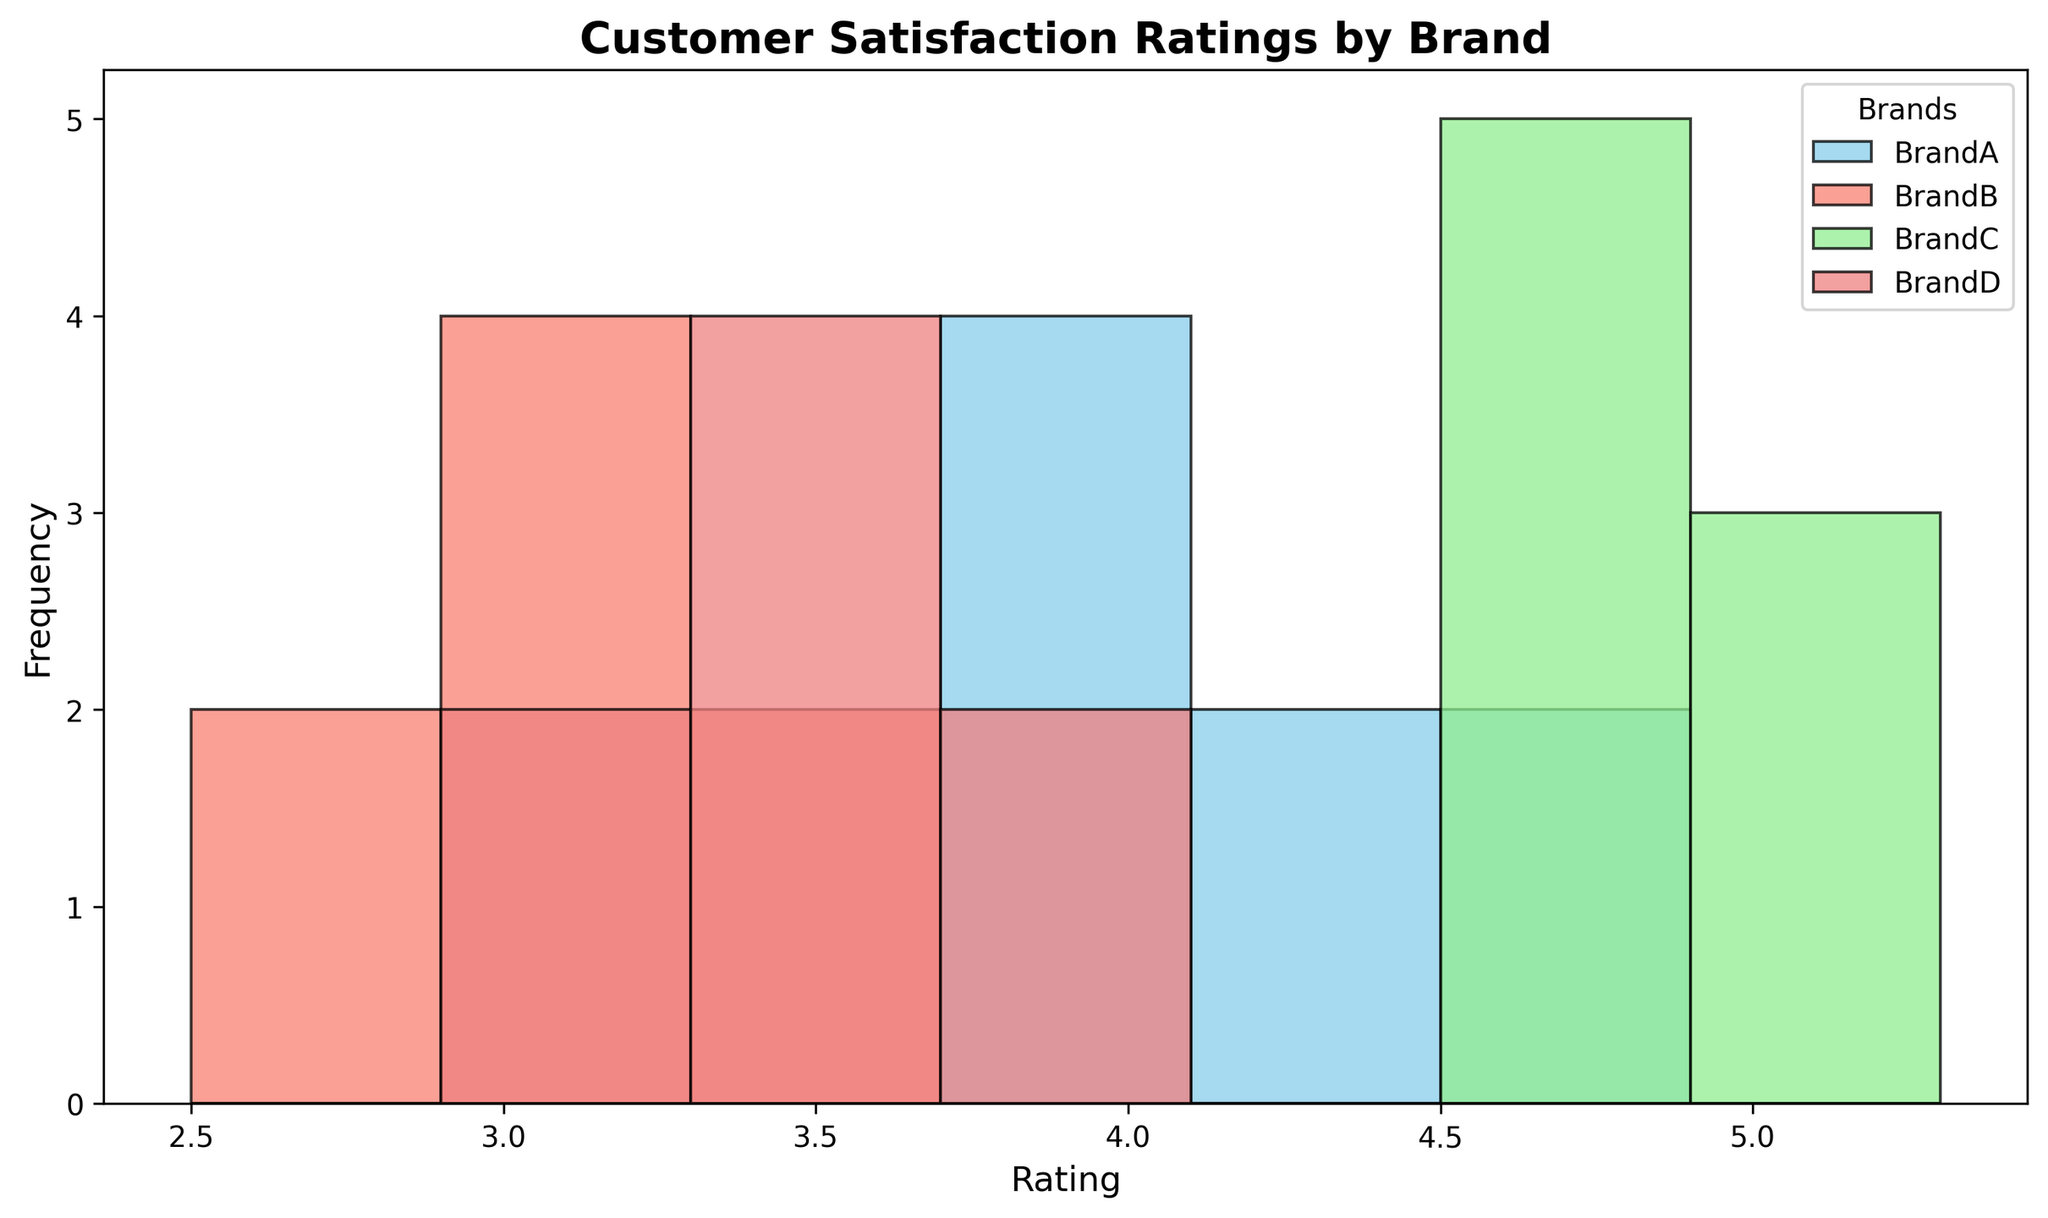Which brand has the highest customer satisfaction rating? By looking at the histogram, the highest rating observed is 5.0 under BrandC.
Answer: BrandC Which brands have ratings predominantly above 4.0? Brands with most of their ratings above 4.0 can be seen from the histograms. BrandA and BrandC have the majority of their ratings above 4.0.
Answer: BrandA, BrandC Which brand has the lowest maximum rating? By examining the histograms, BrandB has the lowest maximum rating, which is around 3.5.
Answer: BrandB Which brand shows the greatest variability in ratings? The variability can be observed by looking at the spread of the bars in the histogram. BrandA shows ratings ranging from about 3.7 to 4.8, indicating higher variability compared to other brands.
Answer: BrandA How does the mean rating of BrandA compare to the mean rating of BrandB? By visual inspection, BrandA has ratings ranging around 3.7 to 4.8 while BrandB ranges from about 2.7 to 3.5. The mean rating of BrandA is likely higher than that of BrandB.
Answer: BrandA is higher Which brand received the most consistent (least variable) ratings? Consistency is indicated by the tight clustering of bars in the histogram. BrandC has ratings tightly clustered around 4.7 to 5.0, indicating the least variability.
Answer: BrandC Which brand has the most customer ratings within the 3.2 to 3.4 range? By looking at the bars within the 3.2 to 3.4 range, it's clear that BrandD has the highest frequency of ratings in this range.
Answer: BrandD If you were to choose a product based solely on customer satisfaction, which brand would you choose? The choice should be based on the highest ratings observed in the histogram. BrandC, with ratings consistently around 4.6 to 5.0, would be the preferred choice for customer satisfaction.
Answer: BrandC 